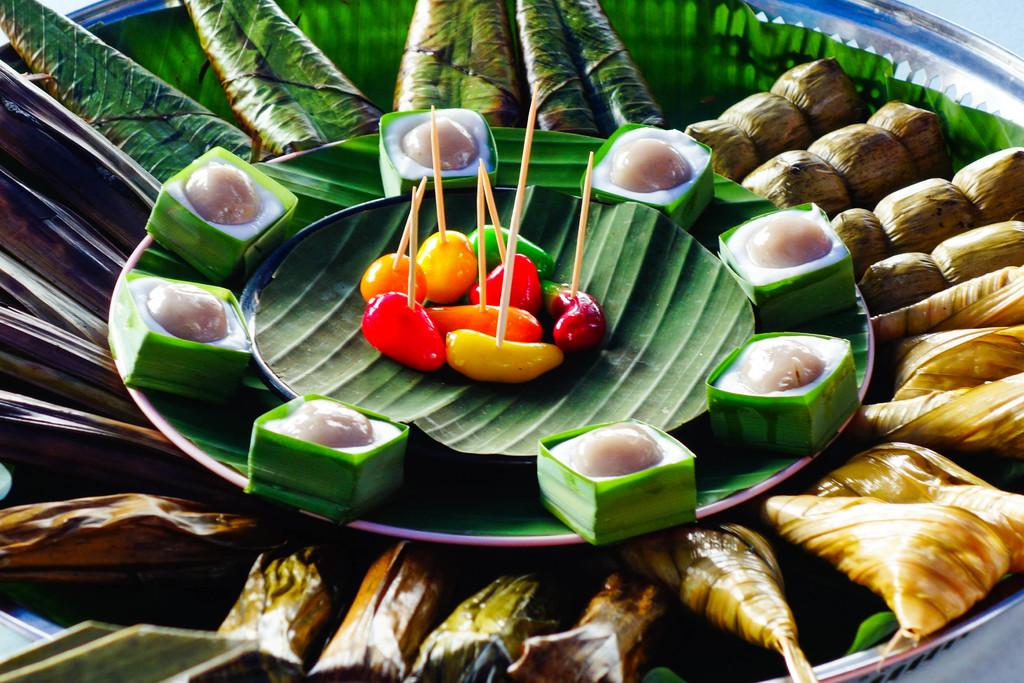What is located in the foreground of the image? There are food items on a platter in the foreground of the image. What can be observed on the food items? The food items have leaves on them. What is stacked on top of the first platter? There is another platter on top of the first platter, and it also contains food items. How are the cherries presented on the food items? Cherries with toothpicks are present on the food items. What type of jam is being served with the food items in the image? There is no jam present in the image; the food items have leaves and cherries with toothpicks on them. 